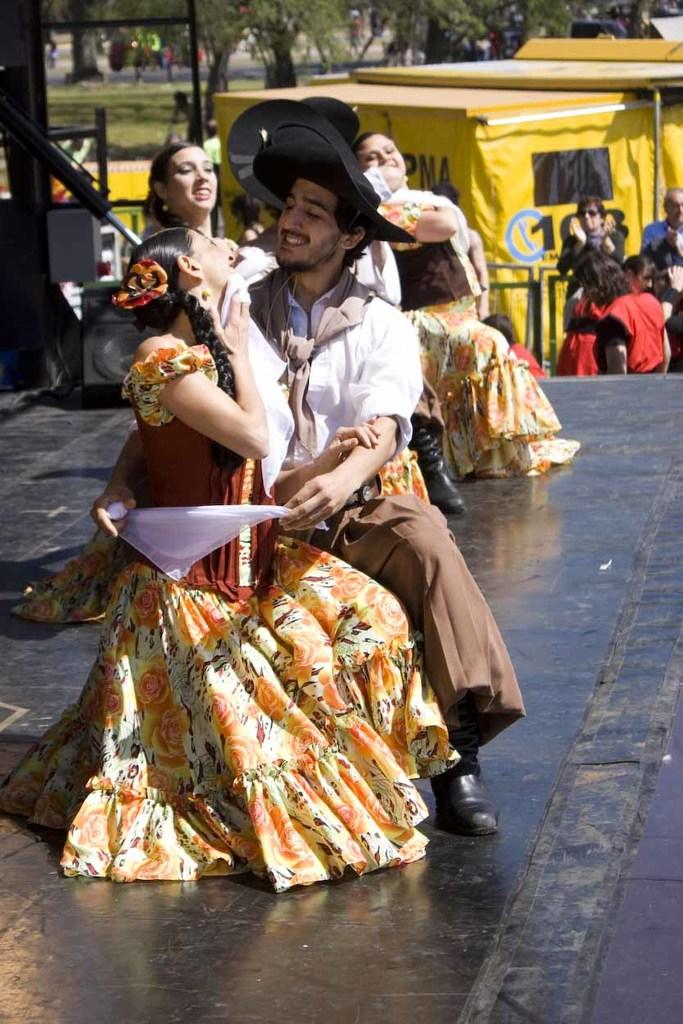What are the couples on the stage doing? The couples on the stage are dancing. What can be seen in the background of the image? In the background, there are persons standing, poles, trees, and grass on the ground. Can you describe the setting of the image? The image shows a stage with couples dancing, and the background features a more natural setting with trees and grass. How much sugar is being used by the couples while dancing in the image? There is no indication of sugar being used in the image; the couples are simply dancing on the stage. 